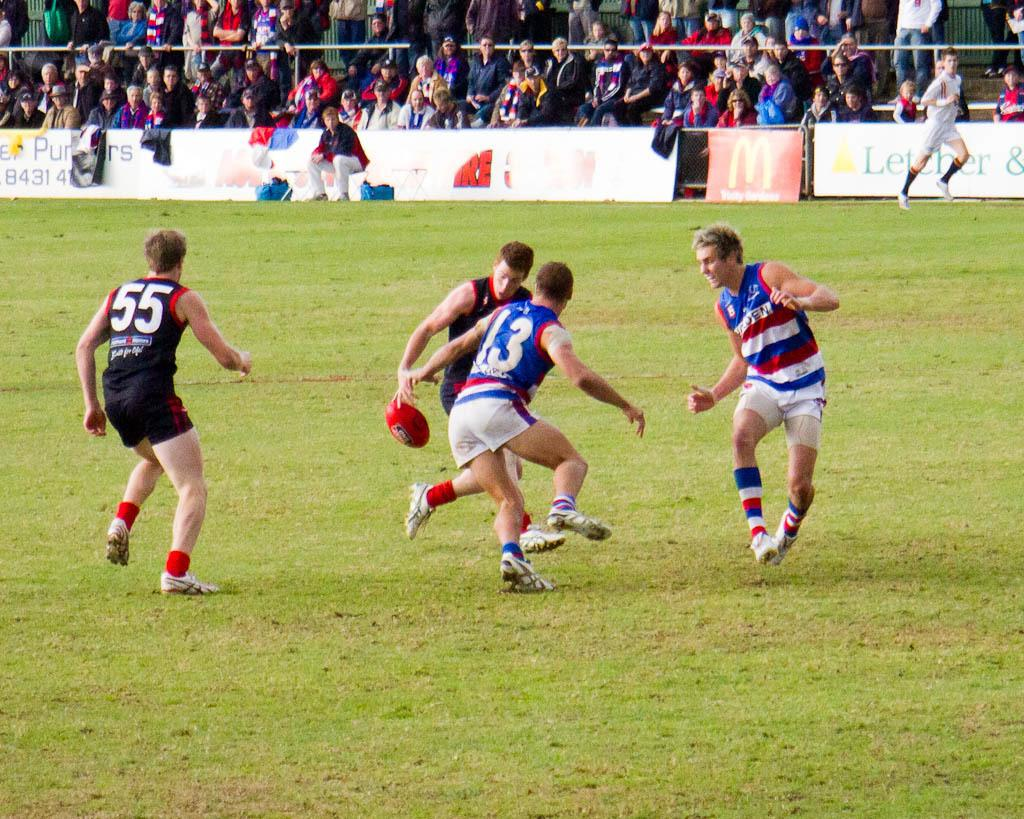Provide a one-sentence caption for the provided image. A rugby match is being played in a field where Mcdonald's advertisement can be seen. 